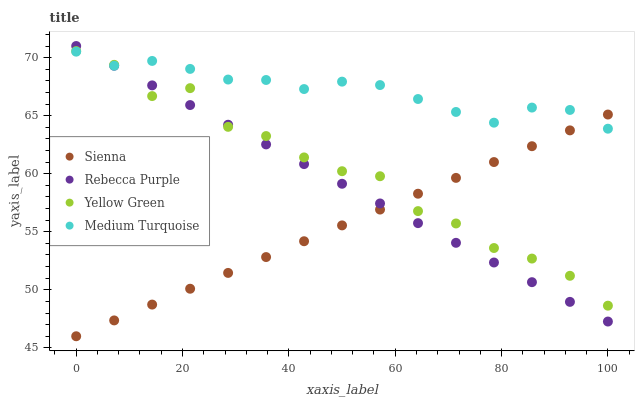Does Sienna have the minimum area under the curve?
Answer yes or no. Yes. Does Medium Turquoise have the maximum area under the curve?
Answer yes or no. Yes. Does Rebecca Purple have the minimum area under the curve?
Answer yes or no. No. Does Rebecca Purple have the maximum area under the curve?
Answer yes or no. No. Is Rebecca Purple the smoothest?
Answer yes or no. Yes. Is Yellow Green the roughest?
Answer yes or no. Yes. Is Medium Turquoise the smoothest?
Answer yes or no. No. Is Medium Turquoise the roughest?
Answer yes or no. No. Does Sienna have the lowest value?
Answer yes or no. Yes. Does Rebecca Purple have the lowest value?
Answer yes or no. No. Does Rebecca Purple have the highest value?
Answer yes or no. Yes. Does Medium Turquoise have the highest value?
Answer yes or no. No. Does Yellow Green intersect Sienna?
Answer yes or no. Yes. Is Yellow Green less than Sienna?
Answer yes or no. No. Is Yellow Green greater than Sienna?
Answer yes or no. No. 